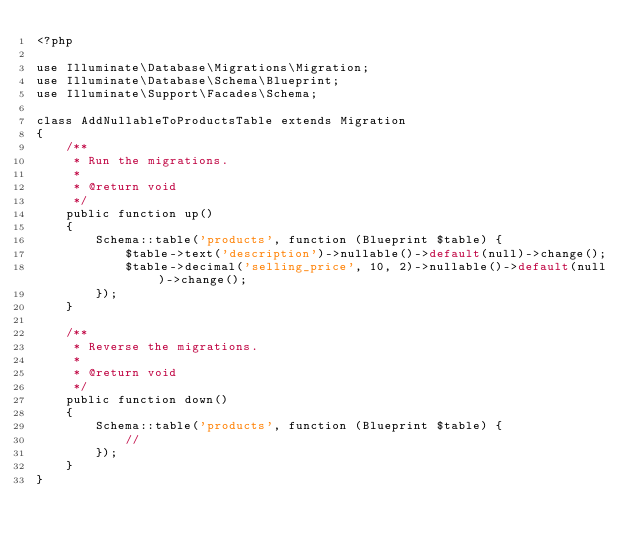<code> <loc_0><loc_0><loc_500><loc_500><_PHP_><?php

use Illuminate\Database\Migrations\Migration;
use Illuminate\Database\Schema\Blueprint;
use Illuminate\Support\Facades\Schema;

class AddNullableToProductsTable extends Migration
{
    /**
     * Run the migrations.
     *
     * @return void
     */
    public function up()
    {
        Schema::table('products', function (Blueprint $table) {
            $table->text('description')->nullable()->default(null)->change();
            $table->decimal('selling_price', 10, 2)->nullable()->default(null)->change();
        });
    }

    /**
     * Reverse the migrations.
     *
     * @return void
     */
    public function down()
    {
        Schema::table('products', function (Blueprint $table) {
            //
        });
    }
}
</code> 